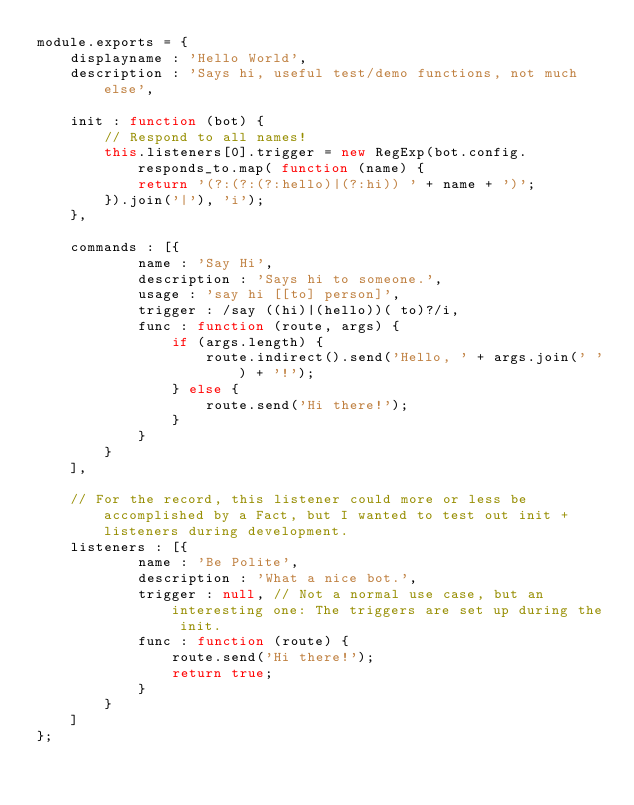<code> <loc_0><loc_0><loc_500><loc_500><_JavaScript_>module.exports = {
    displayname : 'Hello World',
    description : 'Says hi, useful test/demo functions, not much else',

    init : function (bot) {
        // Respond to all names!
        this.listeners[0].trigger = new RegExp(bot.config.responds_to.map( function (name) {
            return '(?:(?:(?:hello)|(?:hi)) ' + name + ')';
        }).join('|'), 'i');
    },

    commands : [{
            name : 'Say Hi',
            description : 'Says hi to someone.',
            usage : 'say hi [[to] person]',
            trigger : /say ((hi)|(hello))( to)?/i,
            func : function (route, args) {
                if (args.length) {
                    route.indirect().send('Hello, ' + args.join(' ') + '!');
                } else {
                    route.send('Hi there!');
                }
            }
        }
    ],

    // For the record, this listener could more or less be accomplished by a Fact, but I wanted to test out init + listeners during development.
    listeners : [{
            name : 'Be Polite',
            description : 'What a nice bot.',
            trigger : null, // Not a normal use case, but an interesting one: The triggers are set up during the init.
            func : function (route) {
                route.send('Hi there!');
                return true;
            }
        }
    ]
};
</code> 